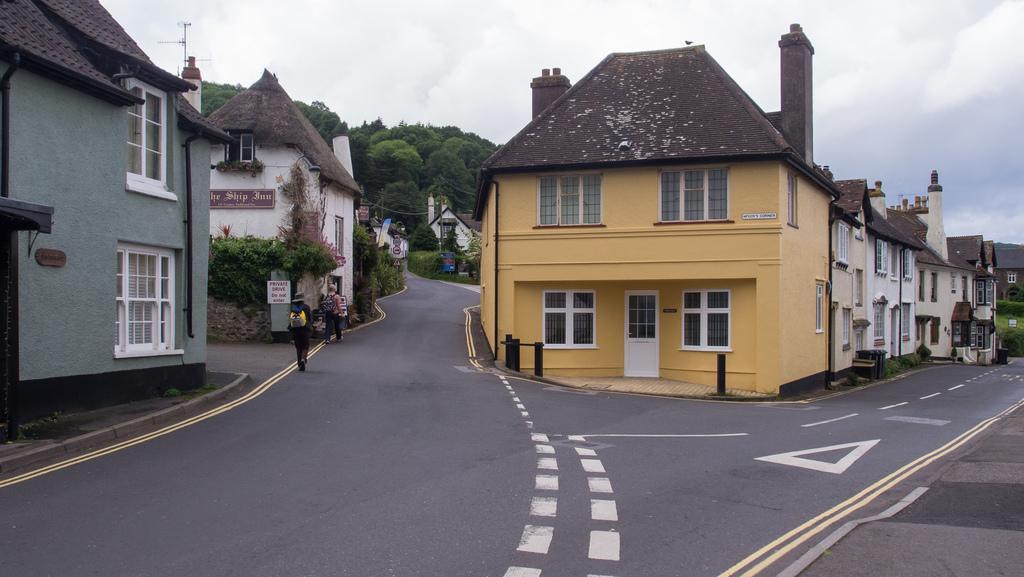Could you give a brief overview of what you see in this image? In the middle of the image we can see some buildings, trees, plants and two persons walking on the road. At the top of the image there are some clouds in the sky. 